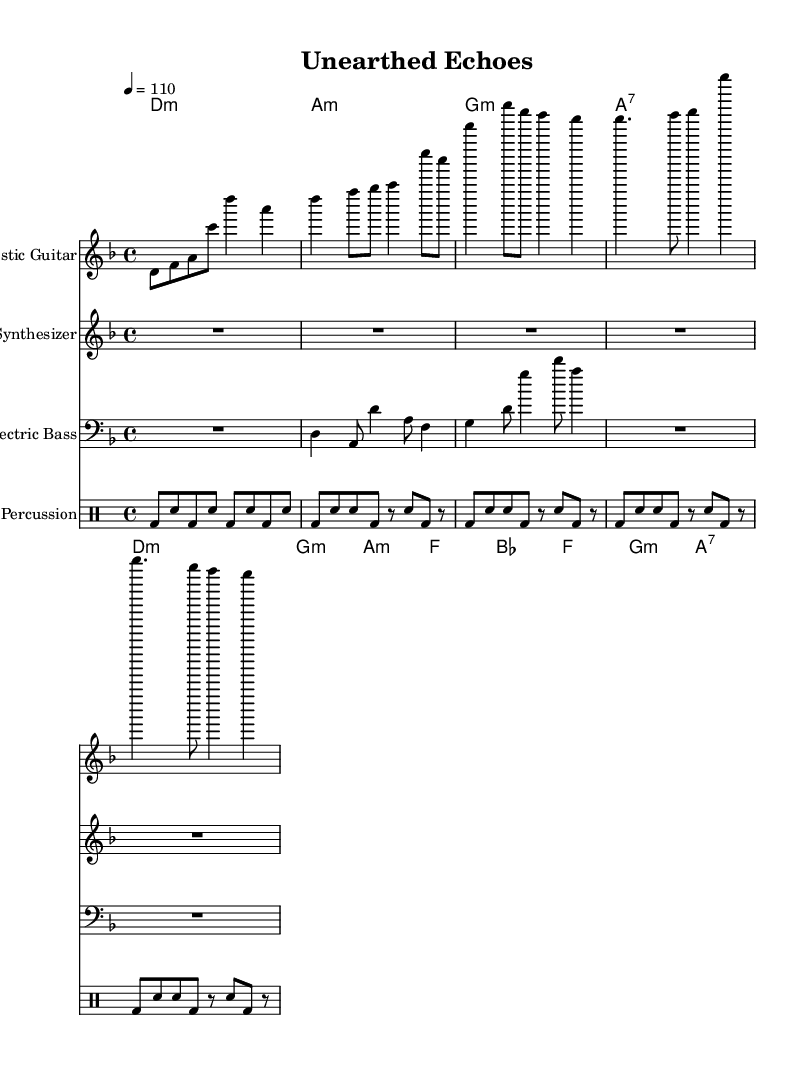What is the key signature of this music? The key signature is D minor, which includes one flat (B flat). This is indicated in the music sheet by the presence of the B flat note.
Answer: D minor What is the time signature of this music? The time signature is 4/4, which indicates that each measure contains four beats and the quarter note gets one beat. This is typically found at the beginning of the score.
Answer: 4/4 What is the tempo marking of the piece? The tempo marking is 110 beats per minute, specified at the beginning of the score indicating the speed at which the music should be played.
Answer: 110 Which instruments are used in this piece? The instruments used are Acoustic Guitar, Synthesizer, Electric Bass, and Percussion. This can be seen in the score layout, where each instrument is labeled clearly at the start of its respective staff.
Answer: Acoustic Guitar, Synthesizer, Electric Bass, Percussion How many measures are there in the chorus section? There are four measures in the chorus section, which can be counted in the corresponding staff where the chorus is notated. Each measure is separated by a vertical line.
Answer: 4 What type of fusion is this piece categorized as? This piece is categorized as acoustic-electronic fusion, combining traditional acoustic sounds with electronic elements inspired by archaeological excavation sounds. This is inferred from the instrumentation and overall style.
Answer: Acoustic-electronic fusion What is the function of the synthesizer in this composition? The synthesizer functions as a background ambiance, indicated by the rests in its part throughout the intro and verses, suggesting it supports the main instruments without competing with them directly.
Answer: Background ambiance 